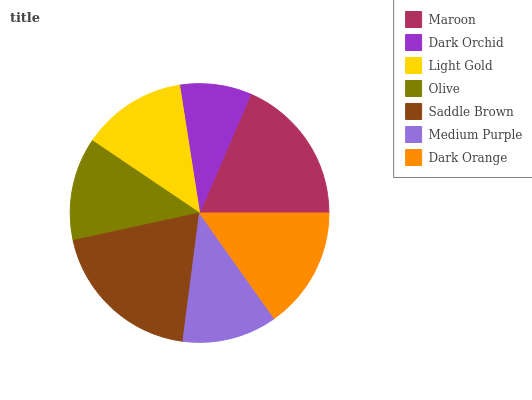Is Dark Orchid the minimum?
Answer yes or no. Yes. Is Saddle Brown the maximum?
Answer yes or no. Yes. Is Light Gold the minimum?
Answer yes or no. No. Is Light Gold the maximum?
Answer yes or no. No. Is Light Gold greater than Dark Orchid?
Answer yes or no. Yes. Is Dark Orchid less than Light Gold?
Answer yes or no. Yes. Is Dark Orchid greater than Light Gold?
Answer yes or no. No. Is Light Gold less than Dark Orchid?
Answer yes or no. No. Is Light Gold the high median?
Answer yes or no. Yes. Is Light Gold the low median?
Answer yes or no. Yes. Is Dark Orange the high median?
Answer yes or no. No. Is Medium Purple the low median?
Answer yes or no. No. 